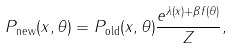Convert formula to latex. <formula><loc_0><loc_0><loc_500><loc_500>P _ { \text {new} } ( x , \theta ) = P _ { \text {old} } ( x , \theta ) \frac { e ^ { \lambda ( x ) + \beta f ( \theta ) } } { Z } ,</formula> 